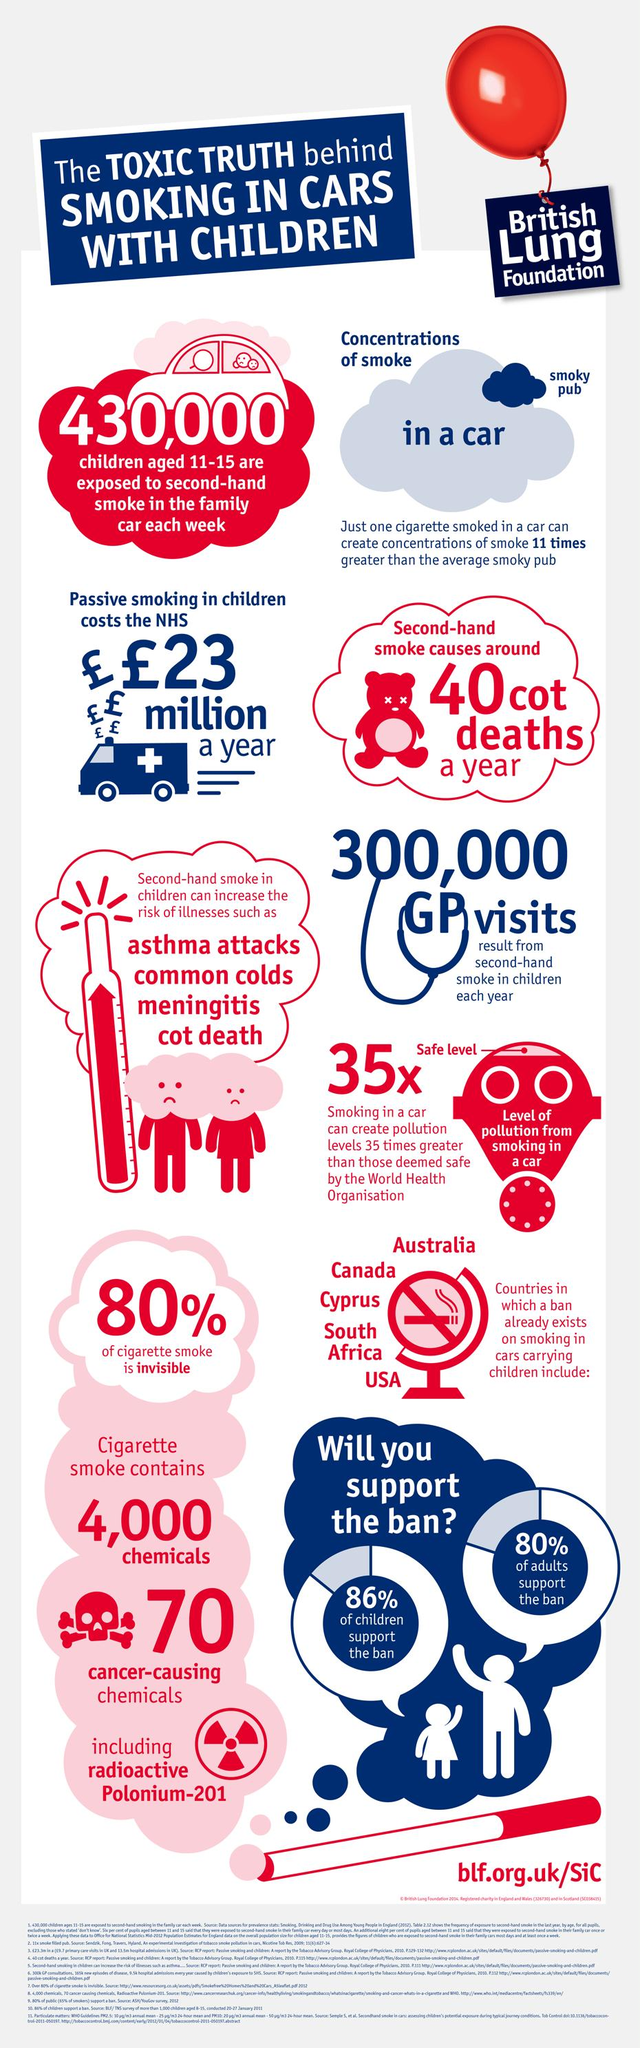Outline some significant characteristics in this image. Approximately 20% of cigarette smoke is visible. It is estimated that 20% of adults did not support the implementation of a ban on cigarettes. According to the survey, 14% of children did not support the cigarette ban. The individual had 300,000 GP visits. There are approximately 4,000 chemicals present in cigarette smoke, which can have harmful effects on human health. 